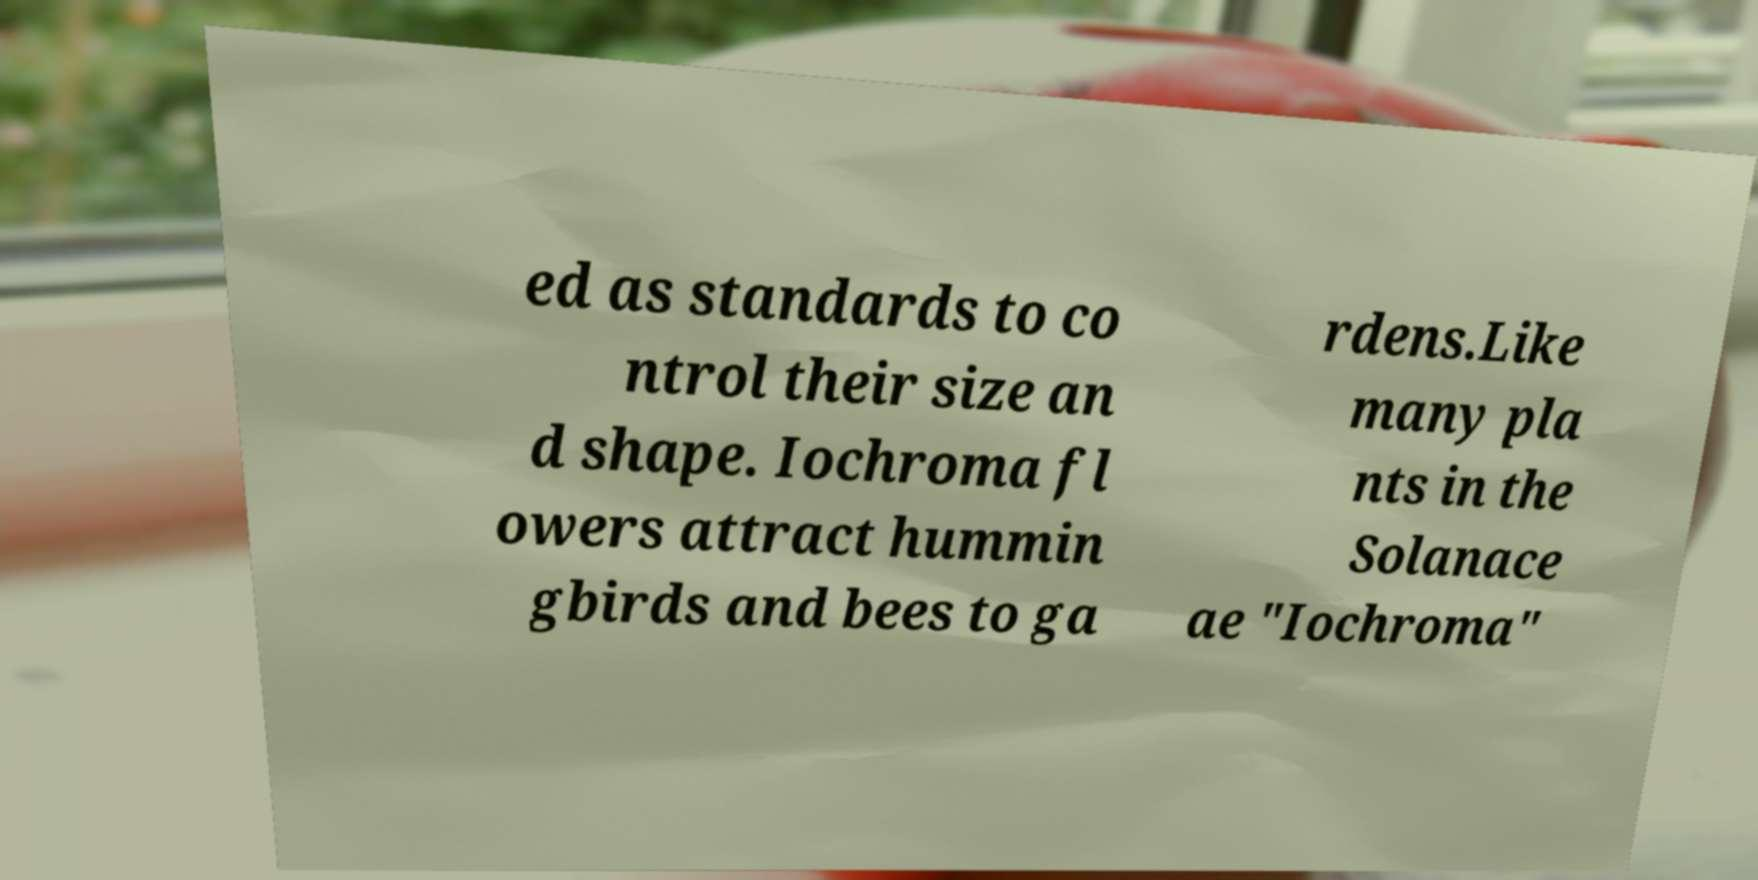Please identify and transcribe the text found in this image. ed as standards to co ntrol their size an d shape. Iochroma fl owers attract hummin gbirds and bees to ga rdens.Like many pla nts in the Solanace ae "Iochroma" 